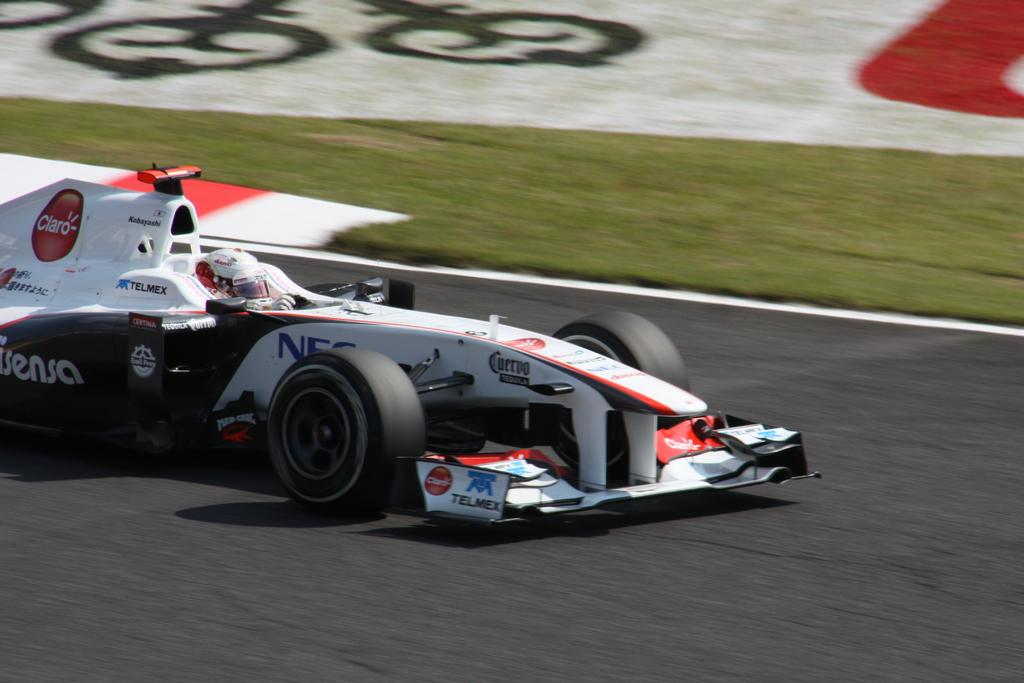What is the setting of the image? The image has an outside view. Can you describe the main subject in the image? There is a person inside a car in the image. Where is the car located in the image? The car is in the middle of the image. What type of account is the person in the car trying to access on the stage? There is no stage or account mentioned in the image; it only shows a person inside a car in an outside view. 